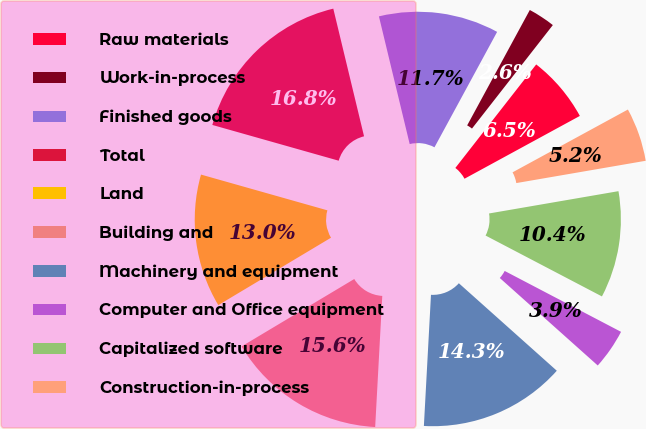Convert chart. <chart><loc_0><loc_0><loc_500><loc_500><pie_chart><fcel>Raw materials<fcel>Work-in-process<fcel>Finished goods<fcel>Total<fcel>Land<fcel>Building and<fcel>Machinery and equipment<fcel>Computer and Office equipment<fcel>Capitalized software<fcel>Construction-in-process<nl><fcel>6.51%<fcel>2.64%<fcel>11.68%<fcel>16.85%<fcel>12.97%<fcel>15.56%<fcel>14.26%<fcel>3.93%<fcel>10.39%<fcel>5.22%<nl></chart> 